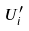<formula> <loc_0><loc_0><loc_500><loc_500>U _ { i } ^ { \prime }</formula> 